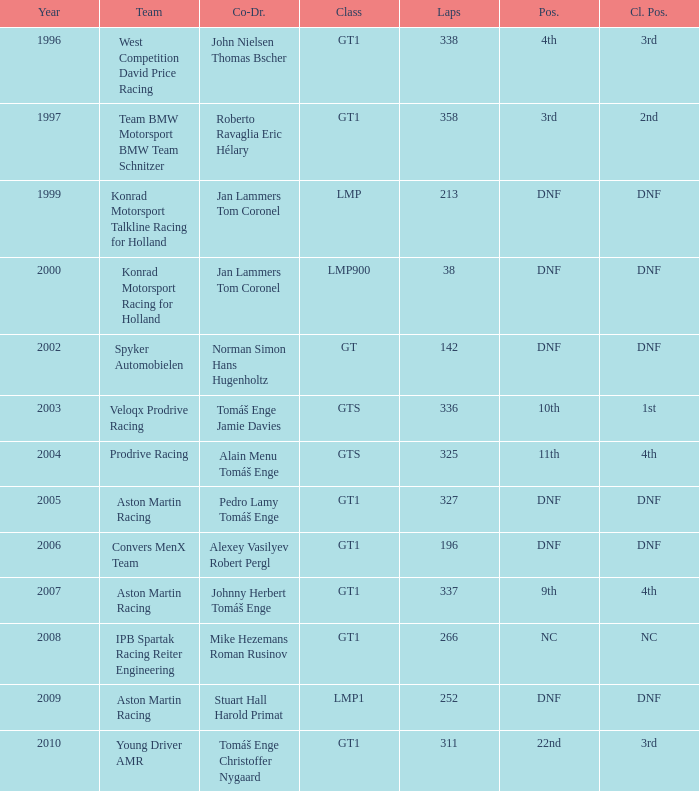Which team finished 3rd in class with 337 laps before 2008? West Competition David Price Racing. 